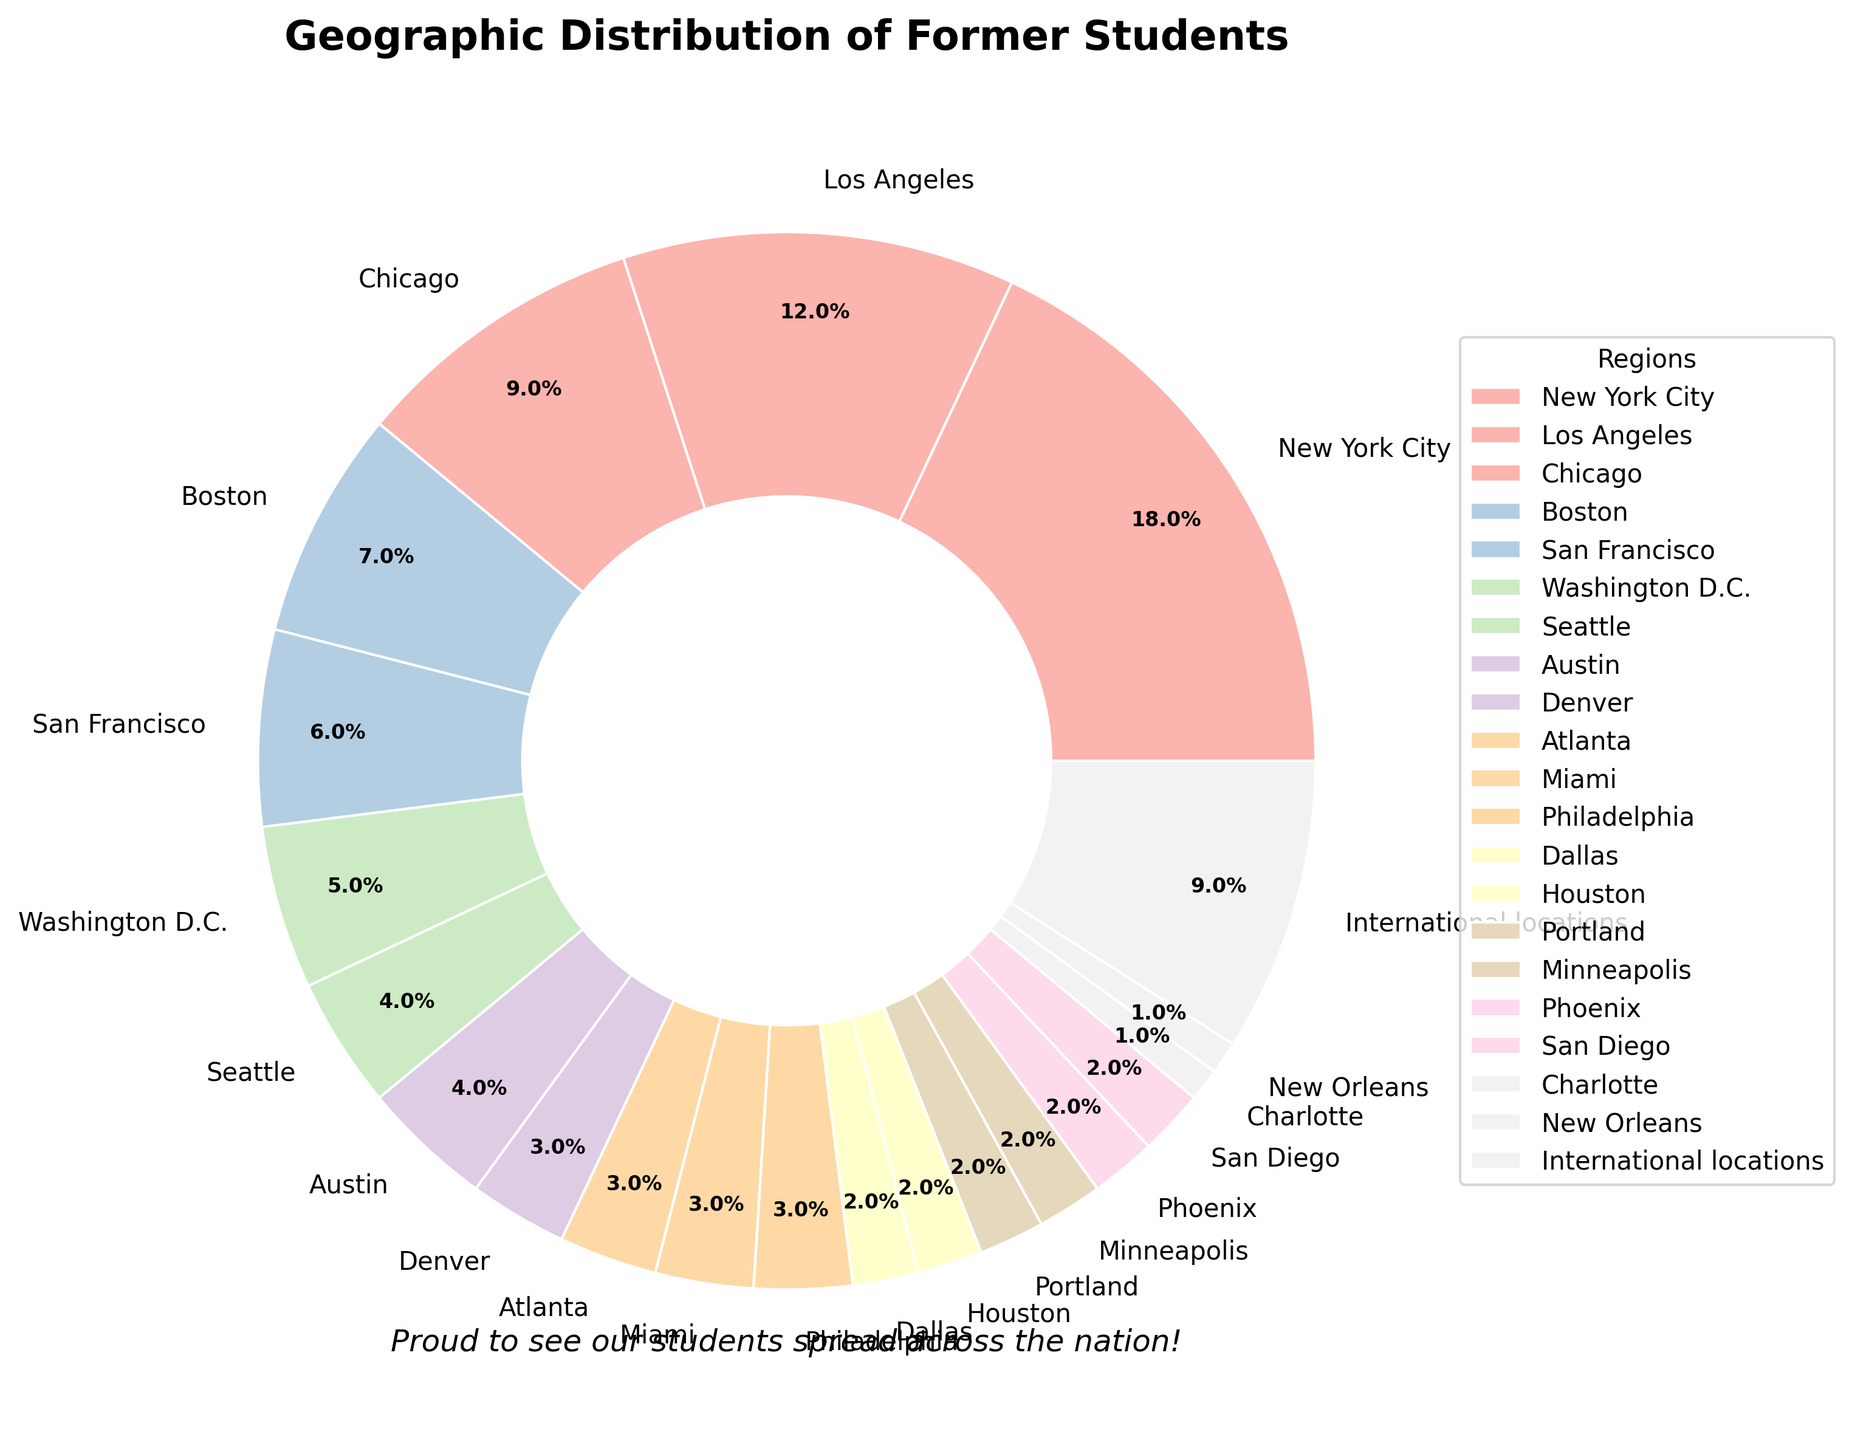What's the combined percentage of former students who settled in New York City and Los Angeles? New York City represents 18% and Los Angeles represents 12%. Adding them gives 18% + 12% = 30%.
Answer: 30% Which regions have a higher percentage of former students, San Francisco or Chicago? San Francisco has 6% and Chicago has 9%. Since 9% is greater than 6%, more students settled in Chicago.
Answer: Chicago How many regions each have exactly 2% of former students? The regions with 2% are Dallas, Houston, Portland, Minneapolis, Phoenix, and San Diego. Counting them gives 6 regions.
Answer: 6 What's the difference in the percentage of former students between Seattle and Denver? Seattle accounts for 4% and Denver for 3%. The difference is 4% - 3% = 1%.
Answer: 1% Which regions have less than or equal to 2% of former students? The regions with 2% or less are Dallas, Houston, Portland, Minneapolis, Phoenix, San Diego, Charlotte, and New Orleans.
Answer: Dallas, Houston, Portland, Minneapolis, Phoenix, San Diego, Charlotte, New Orleans Are there more students settled in international locations or combined in Austin and Washington D.C.? International locations have 9%, Austin has 4%, and Washington D.C. has 5%. Combined, Austin and Washington D.C. have 4% + 5% = 9%. Both have the same percentage.
Answer: Equal Which region has the smallest proportion of former students? The regions with the smallest proportion (1%) are Charlotte and New Orleans.
Answer: Charlotte, New Orleans What's the total percentage of former students settled in all listed regions excluding international locations? Summing the percentages of all listed regions except international locations (100% - 9%) gives 91%.
Answer: 91% Does Miami or Philadelphia have a higher percentage of former students? Miami has 3% and Philadelphia also has 3%. Both regions have the same percentage.
Answer: Equal Which region has the highest percentage of former students and by how much is it higher than the region with the second highest percentage? New York City has the highest percentage (18%), followed by Los Angeles (12%). The difference is 18% - 12% = 6%.
Answer: 6% 